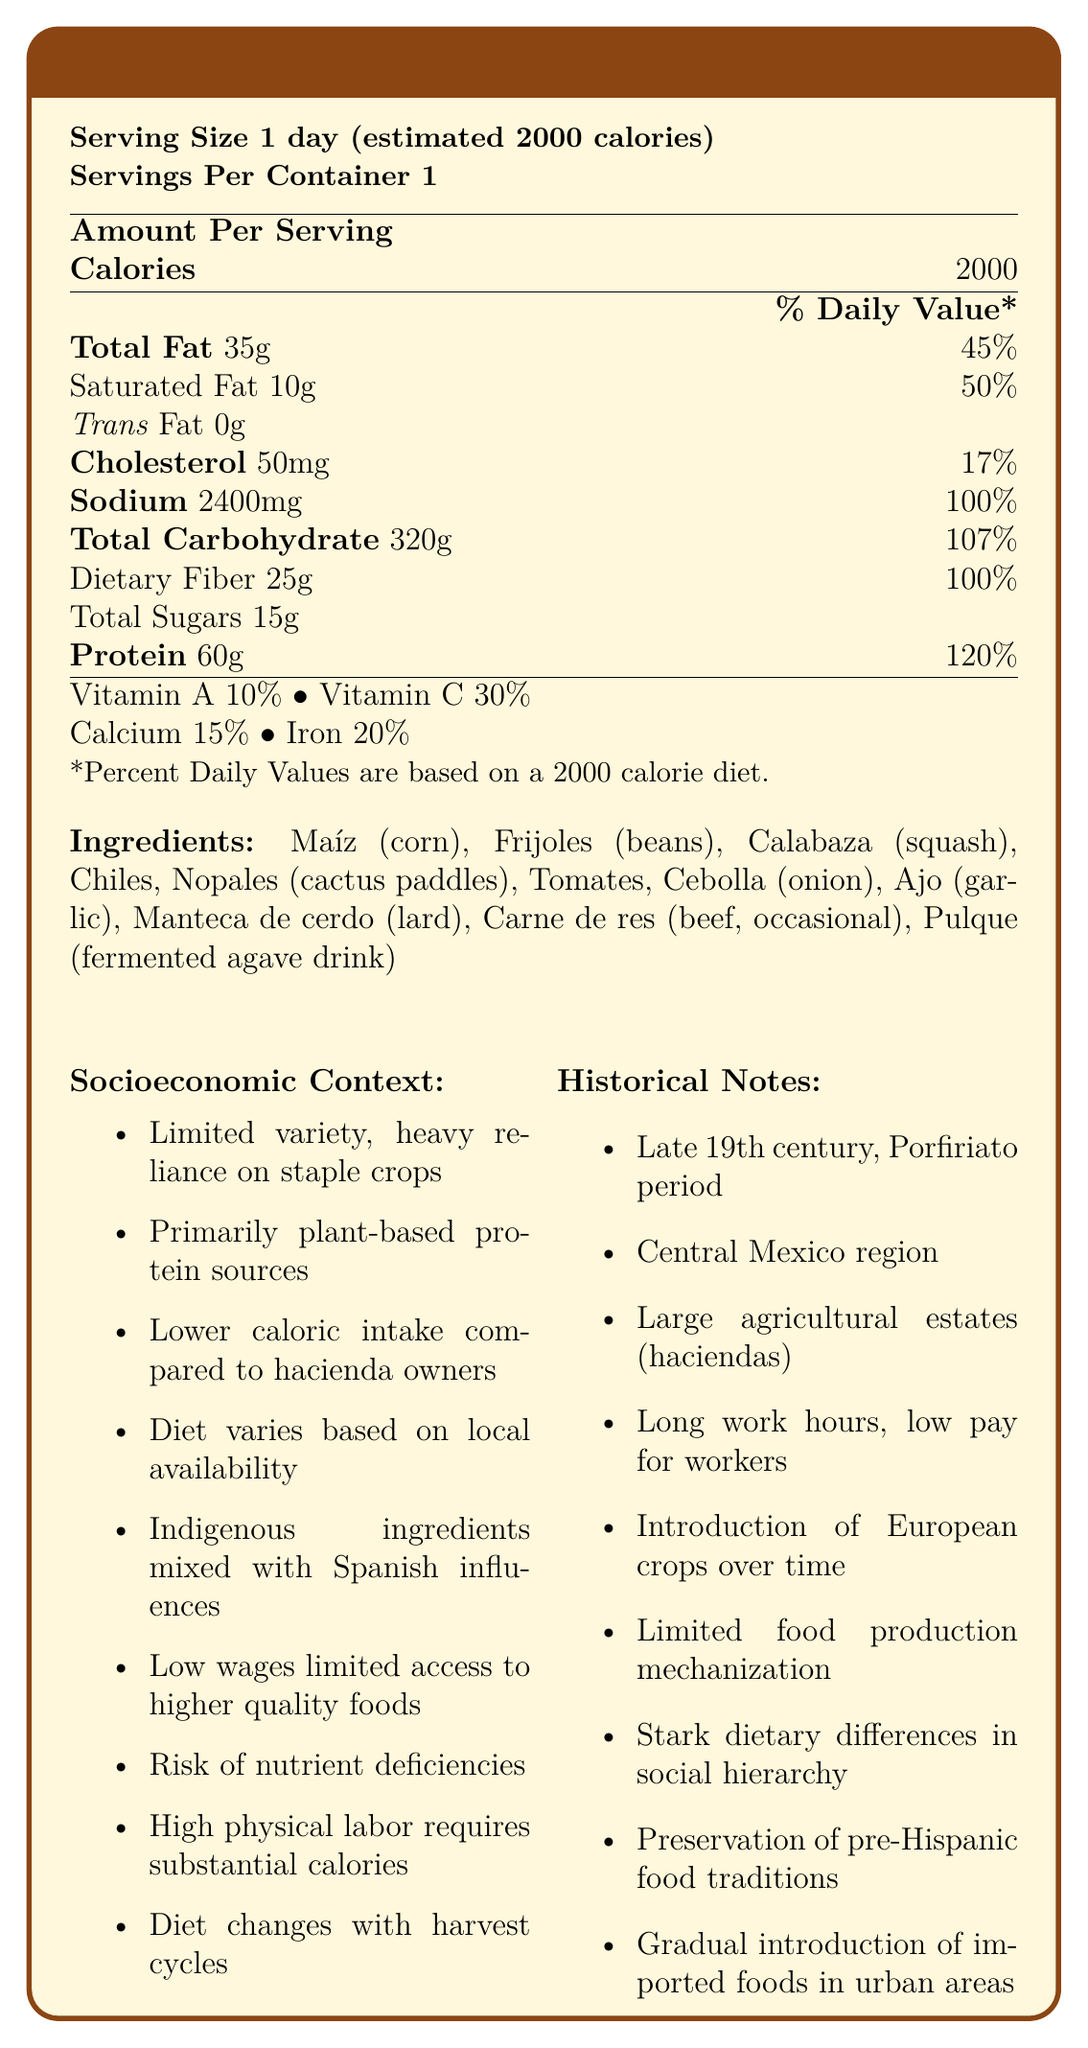How many calories are in a typical hacienda worker's daily diet? The document states that the serving size is based on an estimated 2000 calories per day.
Answer: 2000 What is the amount of sodium in the daily diet of a hacienda worker? The document lists sodium as 2400mg with a 100% daily value.
Answer: 2400mg Which ingredient is occasionally included in the diet? The ingredient list specifies "Carne de res (beef, occasional)".
Answer: Carne de res (beef) What percentage of the daily value of iron does this diet provide? The document specifies that the iron daily value is 20%.
Answer: 20% What are the major protein sources in the hacienda worker's diet? The socioeconomic context section notes that protein sources are primarily plant-based, with occasional meat consumption.
Answer: Primarily plant-based, with occasional meat consumption Which of the following vitamins is provided the least in this diet? A. Vitamin A B. Vitamin C C. Calcium D. Iron The document states Vitamin A at 10%, which is the lowest percentage among the listed vitamins and minerals.
Answer: A. Vitamin A Based on the document, which nutrient is fully provided at 100% of the daily value? A. Dietary Fiber B. Iron C. Vitamin C D. Calcium The document lists dietary fiber at 25g and marks it as 100% of the daily value.
Answer: A. Dietary Fiber Does the diet include any types of sugars? The document lists total sugars at 15g.
Answer: Yes Summarize the main ideas of the document. The document offers a detailed nutrition label focusing on the diet of hacienda workers, with insights into the nutritional content, the socioeconomic factors affecting their diet, and historical notes about the living and working conditions of that period.
Answer: The document provides the nutrition facts for a daily diet of a typical hacienda worker in 19th century Mexico, highlighting the calories, nutrients, and ingredients. It emphasizes the socioeconomic disparities, noting limited variety, reliance on plant-based proteins, and occasional meat. It also provides historical context about the era, region, and labor conditions. What technological advancements affected the food production for hacienda workers? The historical notes section mentions that food production was affected by limited mechanization.
Answer: Limited mechanization What is the predominant type of fat in the diet? Of the total 35g of fat, 10g are saturated, making saturated fat a significant portion.
Answer: Saturated Fat Is the diet more plant-based or animal-based? The socioeconomic context states that protein sources are primarily plant-based, with meat being consumed occasionally.
Answer: Plant-based What is the total carbohydrate content of the diet? The document lists total carbohydrates as 320g with a 107% daily value.
Answer: 320g What aspect of the labor conditions could have contributed to the nutritional needs of the worker? The socioeconomic context mentions that high physical labor requires substantial caloric intake.
Answer: High physical labor How does the diet of hacienda workers compare to that of hacienda owners in terms of animal products? The socioeconomic context section notes that hacienda workers have less diverse diets and fewer animal products compared to hacienda owners.
Answer: Fewer animal products Which era and region are being discussed in the context of this diet? The historical notes section specifies the era as the late 19th century and the region as Central Mexico.
Answer: Late 19th century, Central Mexico What modern foods were beginning to appear in urban areas but not in rural haciendas? The historical notes mention that there was a gradual introduction of imported foods in urban areas.
Answer: Imported foods What is the cultural significance of the ingredients in the diet? The socioeconomic context notes that the diet includes indigenous ingredients mixed with Spanish influences.
Answer: Indigenous ingredients mixed with Spanish influences Based on the document, what socioeconomic factor limited the quality of the hacienda workers' diet? The socioeconomic context section mentions that low wages and debt peonage limited access to higher quality foods.
Answer: Low wages and debt peonage What is the cholesterol content of the diet? The document lists cholesterol at 50mg with a 17% daily value.
Answer: 50mg What percentage of the daily protein needs does this diet meet or exceed? The nutrition facts state that the protein content is 60g, which is 120% of the daily value.
Answer: 120% Can we determine the exact varieties of chiles and tomates included in the diet? The document lists chiles and tomatoes as ingredients but does not specify the exact varieties.
Answer: Cannot be determined 